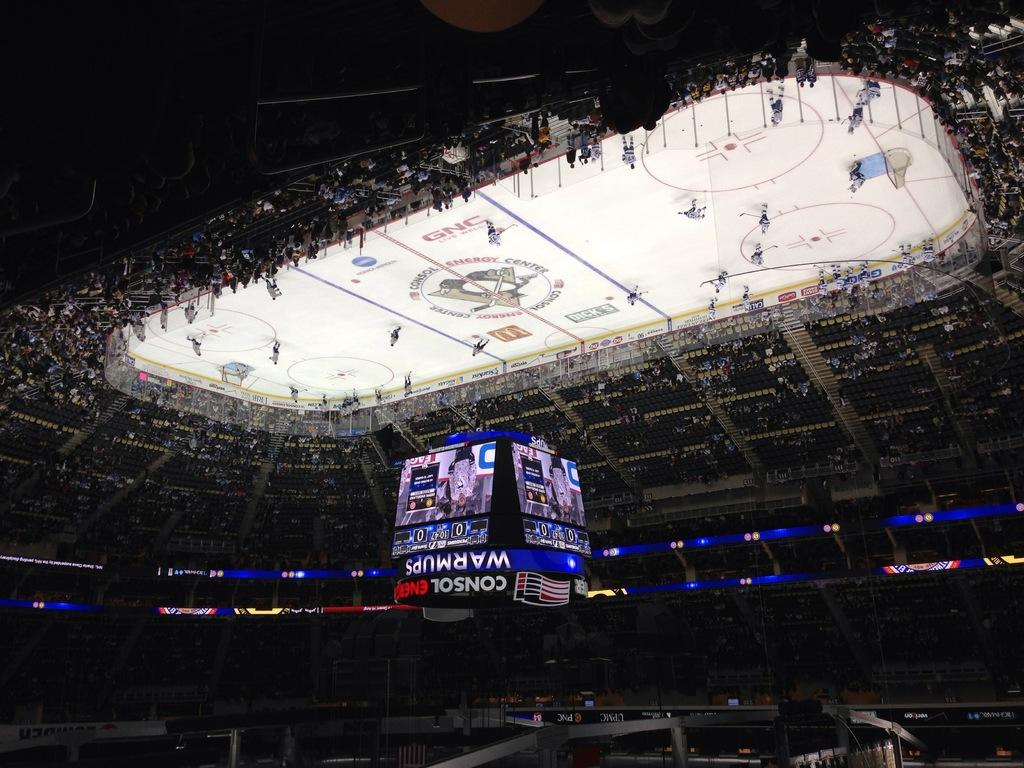Provide a one-sentence caption for the provided image. A hockey rink with teams playing and a scoreboard overheard advising of warmups. 